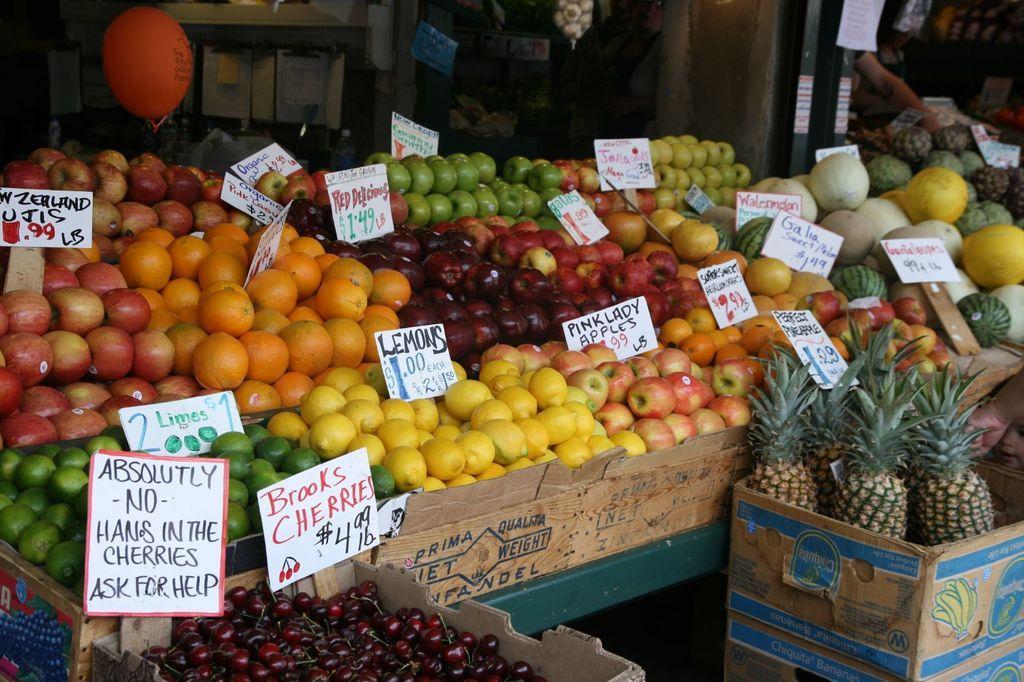Describe this image in one or two sentences. This picture is taken in the fruit shop. In this image, on the right side, we can see a box with some pineapples in it. On the left side, we can also see a box with some cherries. On the left side, we can also see two boards on which it's written some text. In the middle of the image, we can see some fruits like apple, orange and some other, we can also see some boards. In the background, we can see a balloon, wall. On the right side of the image, we can see the hand of a person touching the fruit. 